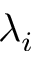<formula> <loc_0><loc_0><loc_500><loc_500>\lambda _ { i }</formula> 